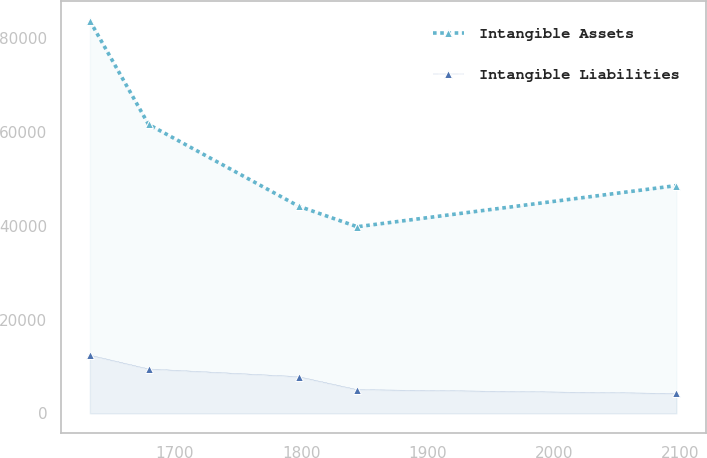Convert chart. <chart><loc_0><loc_0><loc_500><loc_500><line_chart><ecel><fcel>Intangible Assets<fcel>Intangible Liabilities<nl><fcel>1632.61<fcel>83740.5<fcel>12414.2<nl><fcel>1679.05<fcel>61642.8<fcel>9471.97<nl><fcel>1797.8<fcel>44203.1<fcel>7830.24<nl><fcel>1844.24<fcel>39810.1<fcel>5056.15<nl><fcel>2096.99<fcel>48596.2<fcel>4238.59<nl></chart> 